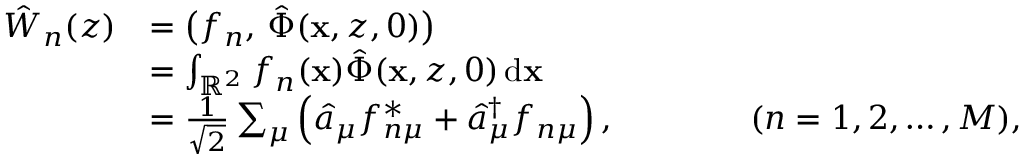Convert formula to latex. <formula><loc_0><loc_0><loc_500><loc_500>\begin{array} { r l } { \hat { W } _ { n } ( z ) } & { = \left ( f _ { n } , \, \hat { \Phi } ( x , z , 0 ) \right ) } \\ & { = \int _ { \mathbb { R } ^ { 2 } } f _ { n } ( x ) \hat { \Phi } ( x , z , 0 ) \, d x } \\ & { = \frac { 1 } { \sqrt { 2 } } \sum _ { \mu } \left ( \hat { a } _ { \mu } f _ { n \mu } ^ { * } + \hat { a } _ { \mu } ^ { \dagger } f _ { n \mu } \right ) , \quad ( n = 1 , 2 , \dots , M ) , } \end{array}</formula> 